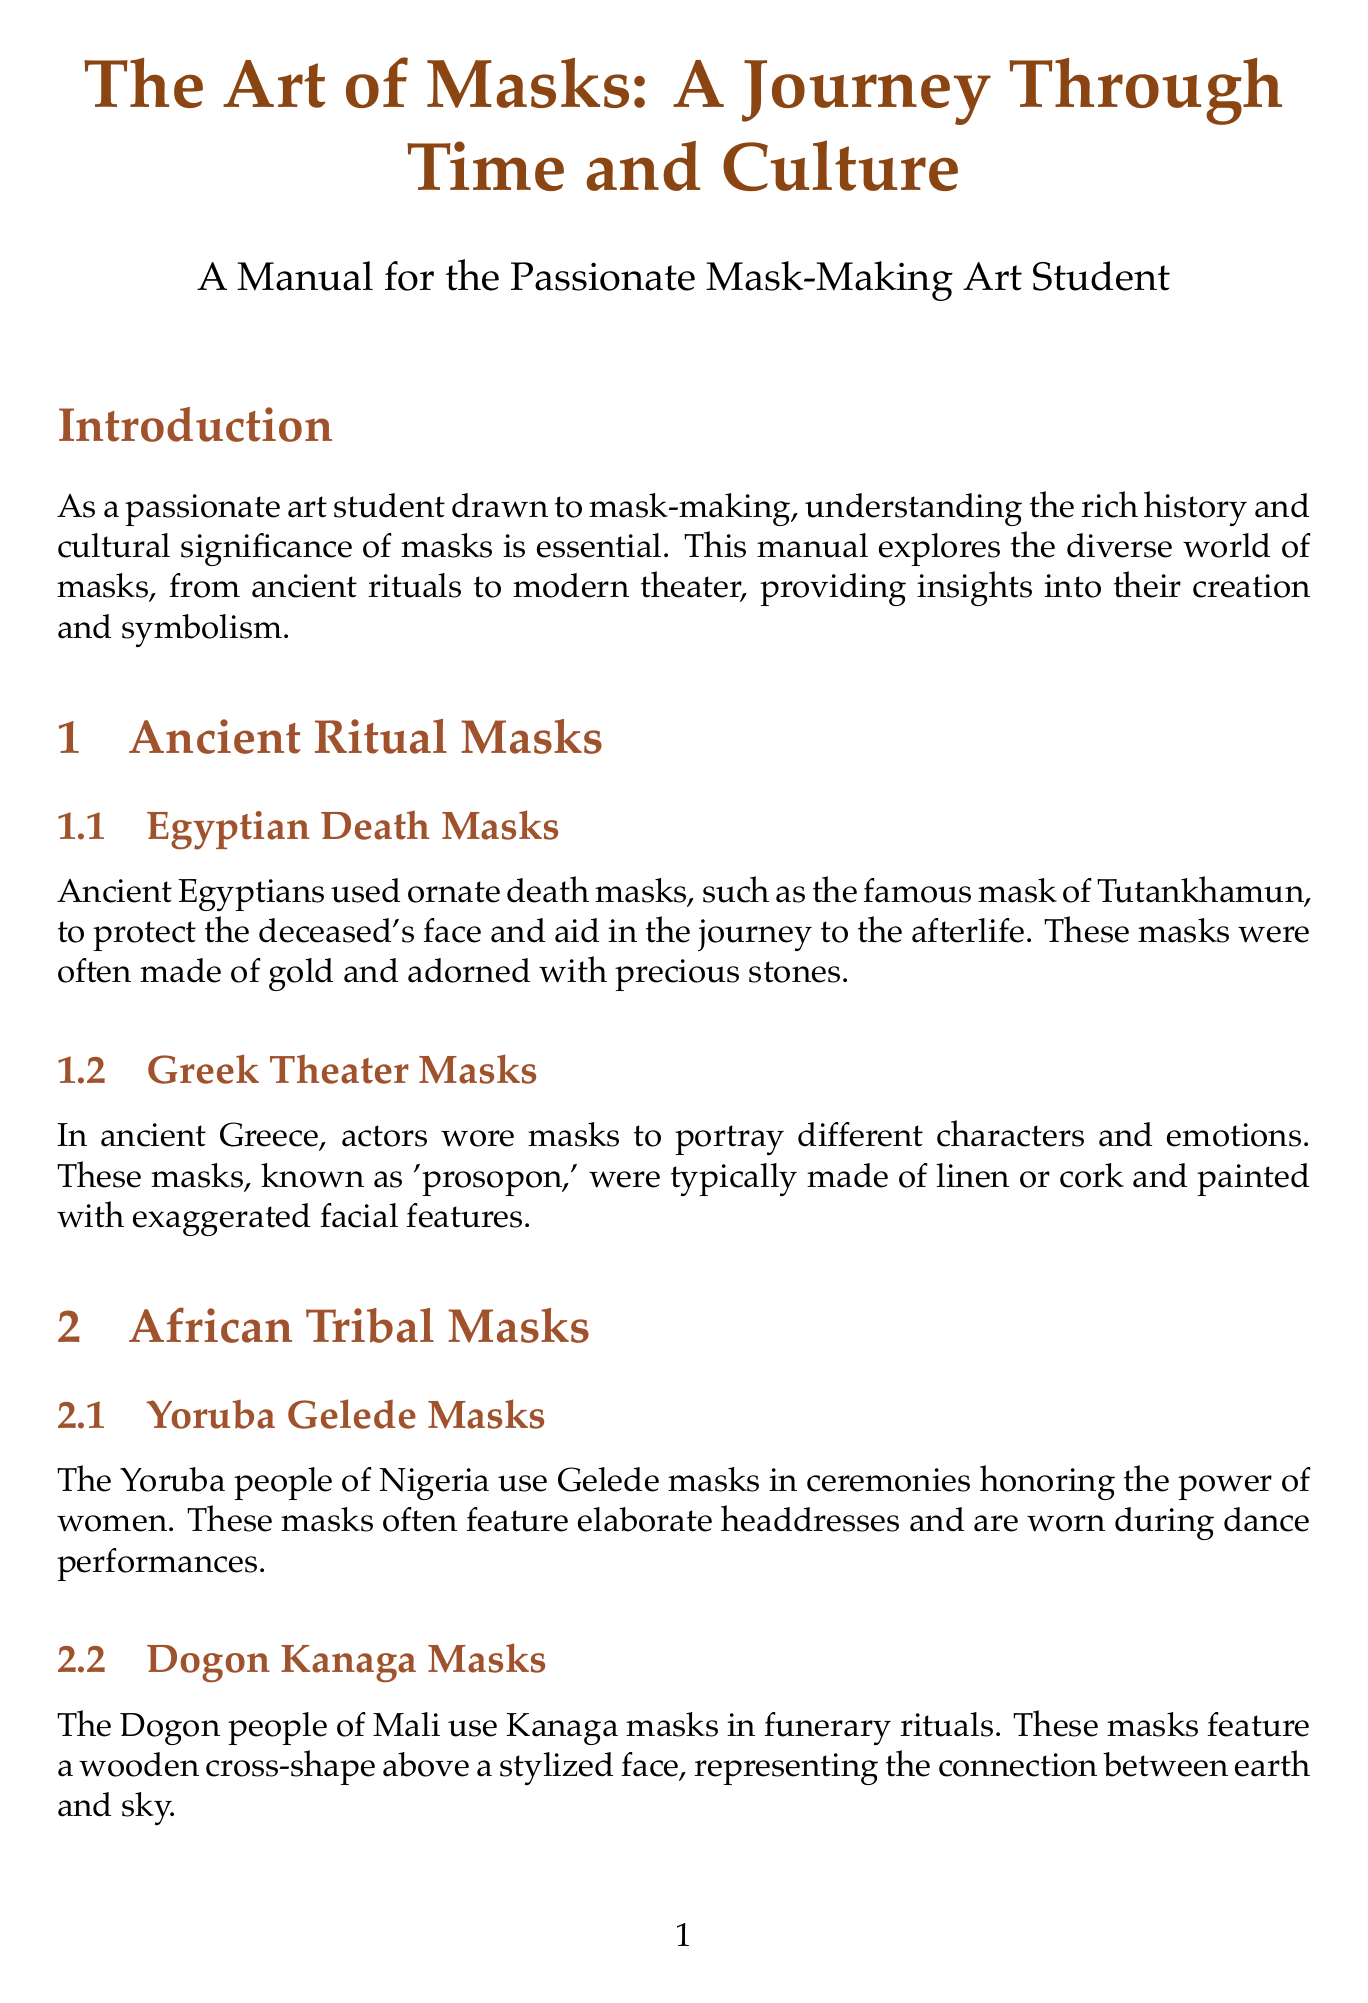What is the title of the manual? The title of the manual is given at the start of the document.
Answer: The Art of Masks: A Journey Through Time and Culture What material is commonly used for Venetian Carnival Masks? The document mentions materials associated with Venetian Carnival Masks specifically.
Answer: Leather or papier-mâché Which culture uses Kanaga masks in funerary rituals? The text states the specific group that employs Kanaga masks for funerary purposes.
Answer: Dogon What type of masks are used in Noh theater? The document identifies the type of masks associated with Noh theater in Japan.
Answer: Omote Who created the masks for the Broadway adaptation of ‘The Lion King’? The document attributes the design of these masks to a specific individual known for their award-winning work.
Answer: Julie Taymor What purpose do Yoruba Gelede masks serve? The document explains the cultural significance of Gelede masks to a specific group.
Answer: Honoring the power of women What is the neutral mask used for in actor training? The text describes the purpose of the neutral mask within the context of theater training.
Answer: Body awareness Which technique allows for intricate designs in modern mask-making? The document discusses contemporary methods that facilitate detailed designs in mask-making.
Answer: 3D printing What is the primary focus of the introduction section? The introduction clearly states its goal in relation to mask-making and cultural significance.
Answer: Understanding the rich history and cultural significance of masks 